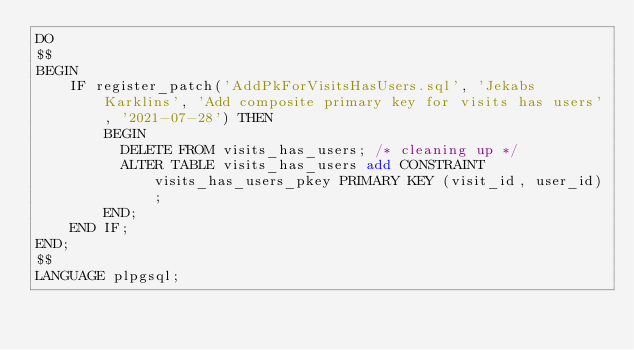<code> <loc_0><loc_0><loc_500><loc_500><_SQL_>DO
$$
BEGIN
	IF register_patch('AddPkForVisitsHasUsers.sql', 'Jekabs Karklins', 'Add composite primary key for visits has users', '2021-07-28') THEN
		BEGIN
		  DELETE FROM visits_has_users; /* cleaning up */
		  ALTER TABLE visits_has_users add CONSTRAINT visits_has_users_pkey PRIMARY KEY (visit_id, user_id);
		END;
	END IF;
END;
$$
LANGUAGE plpgsql;
</code> 